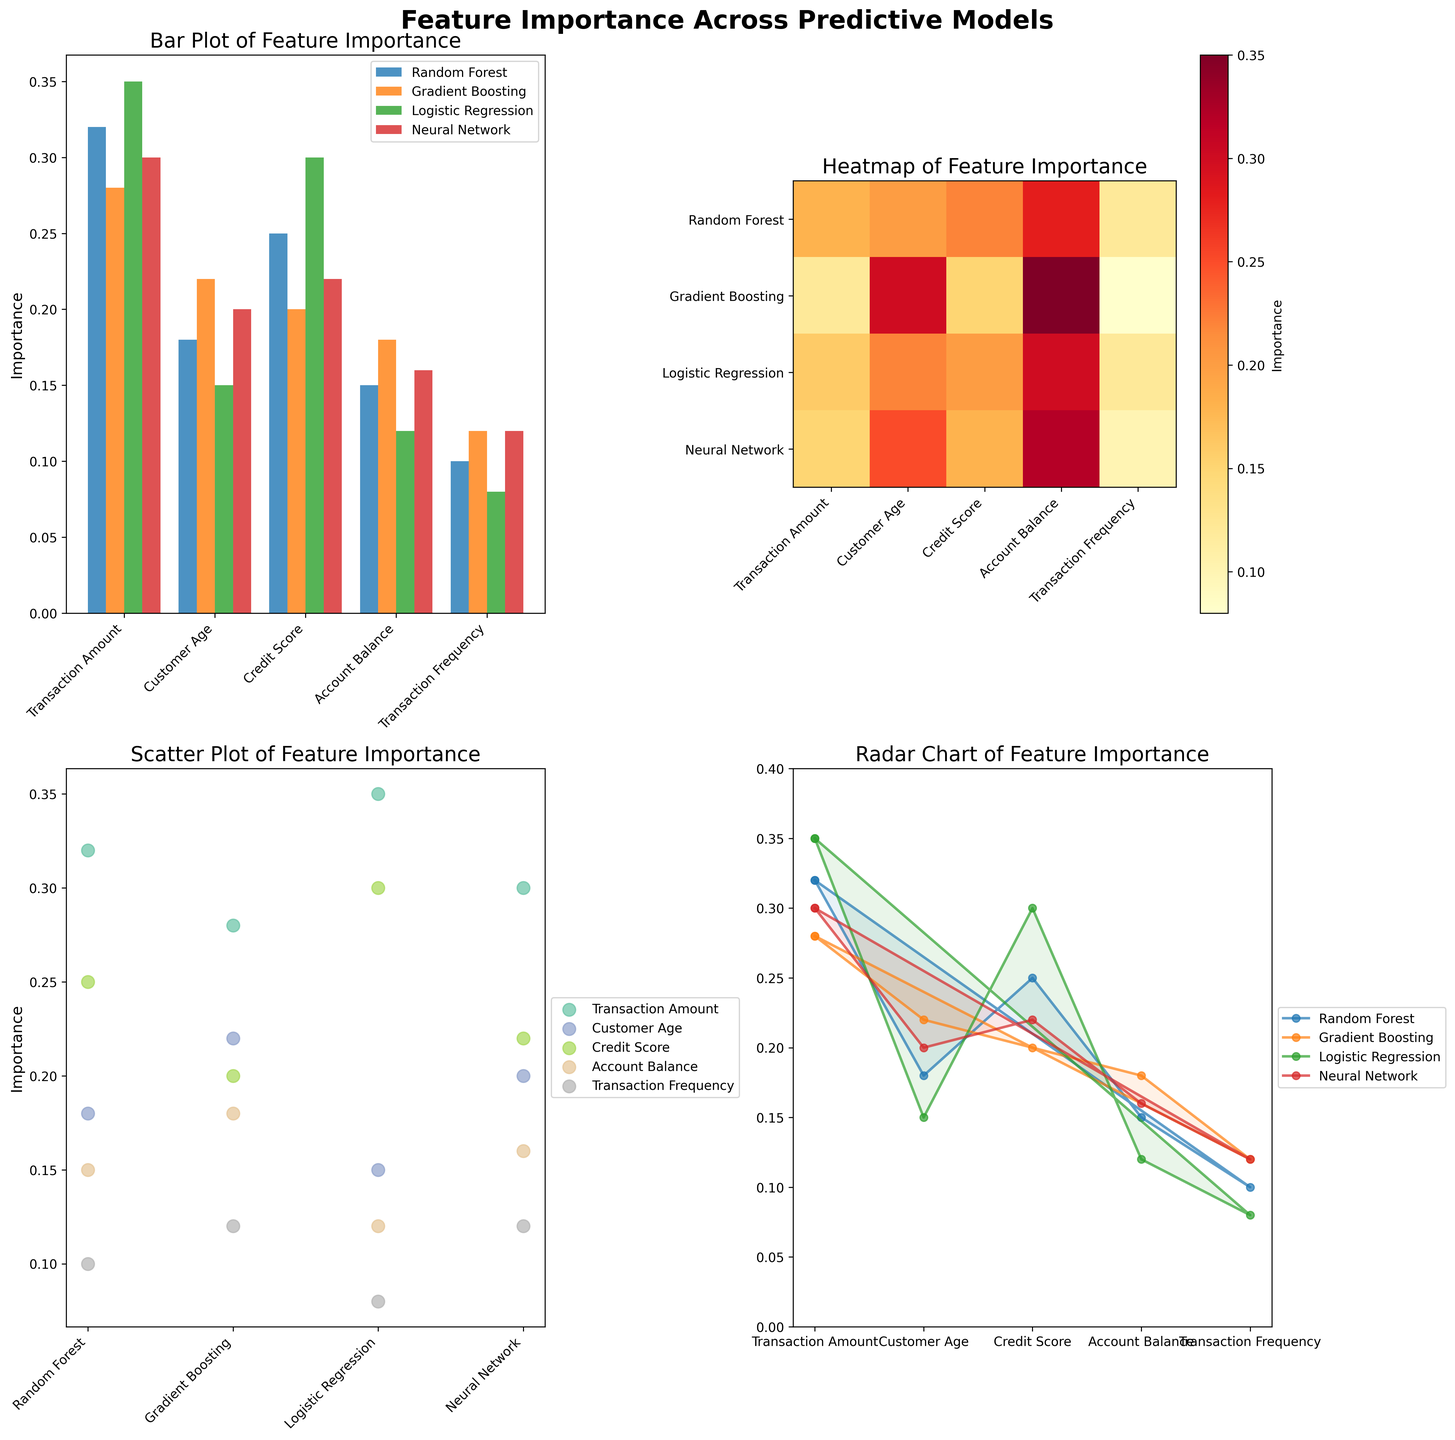Which model has the highest feature importance for 'Transaction Amount' in the bar plot? Locate the 'Transaction Amount' category in the bar plot and find the highest bar among the models. Logistic Regression has the highest bar for 'Transaction Amount'.
Answer: Logistic Regression Which feature has the lowest importance for Random Forest according to the heatmap? Find the row corresponding to Random Forest in the heatmap and identify the feature column with the lowest intensity color. The lowest intensity corresponds to 'Transaction Frequency'.
Answer: Transaction Frequency What's the average importance of 'Credit Score' across all models in the scatter plot? Locate 'Credit Score' points in the scatter plot, sum their importance values, and divide by the number of models (0.25+0.20+0.30+0.22)/4 = 0.2425
Answer: 0.2425 Compare the importance of 'Account Balance' between Gradient Boosting and Neural Network in the radar chart. Find the 'Account Balance' segment for both models in the radar chart and compare their distances from the origin. Gradient Boosting has a longer distance than Neural Network.
Answer: Greater for Gradient Boosting Which feature shows the most consistent importance across all models? Check the length of bars for each feature across all models in the bar plot and compare the consistency. 'Transaction Frequency' has the most similar bar heights across models.
Answer: Transaction Frequency What is the total importance sum of 'Customer Age' across all models in the bar plot? Add the importance values for 'Customer Age' from the bar plot: 0.18 (Random Forest) + 0.22 (Gradient Boosting) + 0.15 (Logistic Regression) + 0.20 (Neural Network) = 0.75
Answer: 0.75 Does any feature have a higher importance in Random Forest than its corresponding importance in Gradient Boosting? Compare each feature's importance in Random Forest to its value in Gradient Boosting in the bar plot. 'Credit Score' (0.25 > 0.20) and 'Transaction Amount' (0.32 > 0.28) are higher in Random Forest.
Answer: Yes Which feature has the biggest difference in importance between any two models? Check the differences in feature importance for each pair of models and find the largest difference. 'Credit Score' has a difference of 0.30 (Logistic Regression) - 0.20 (Gradient Boosting) = 0.10
Answer: Credit Score In the scatter plot, what is the feature importance of 'Transaction Frequency' for Logistic Regression? Identify the 'Transaction Frequency' data point for Logistic Regression in the scatter plot. 'Transaction Frequency' for Logistic Regression is 0.08.
Answer: 0.08 For the radar chart, which model shows the most balanced feature importance distribution? Observe the radar chart and look for the model with the most even distribution of values across all features. Random Forest shows a relatively even distribution compared to others.
Answer: Random Forest 